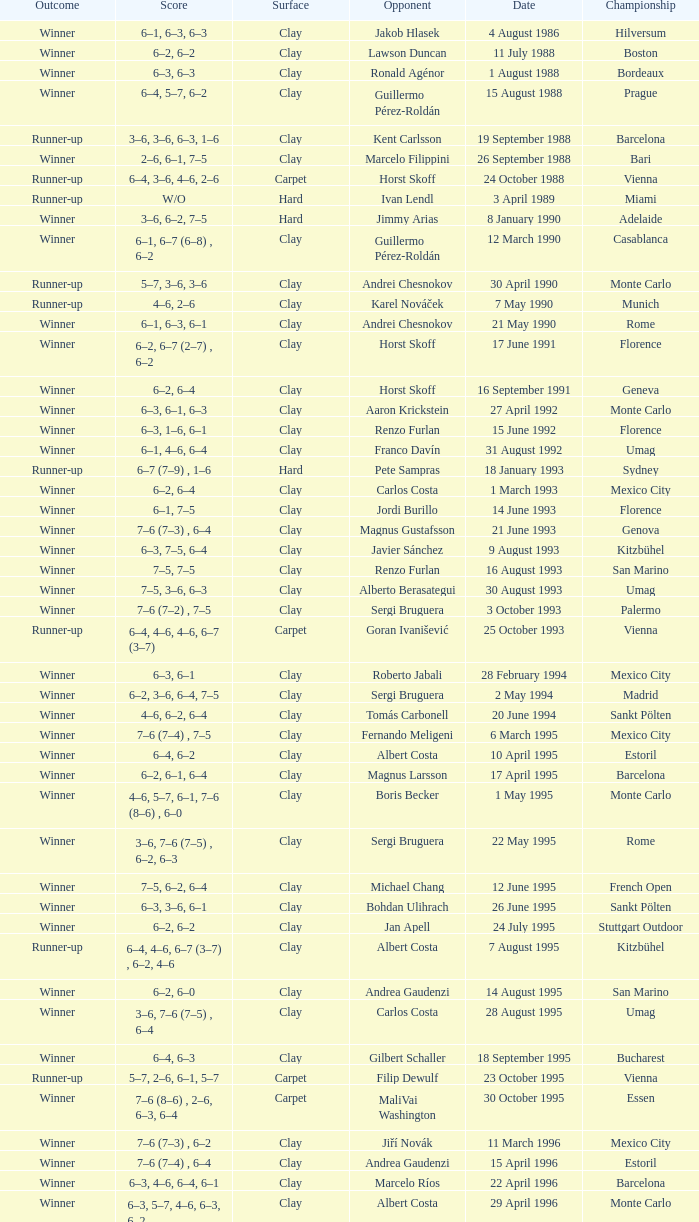What is the surface on 21 june 1993? Clay. 